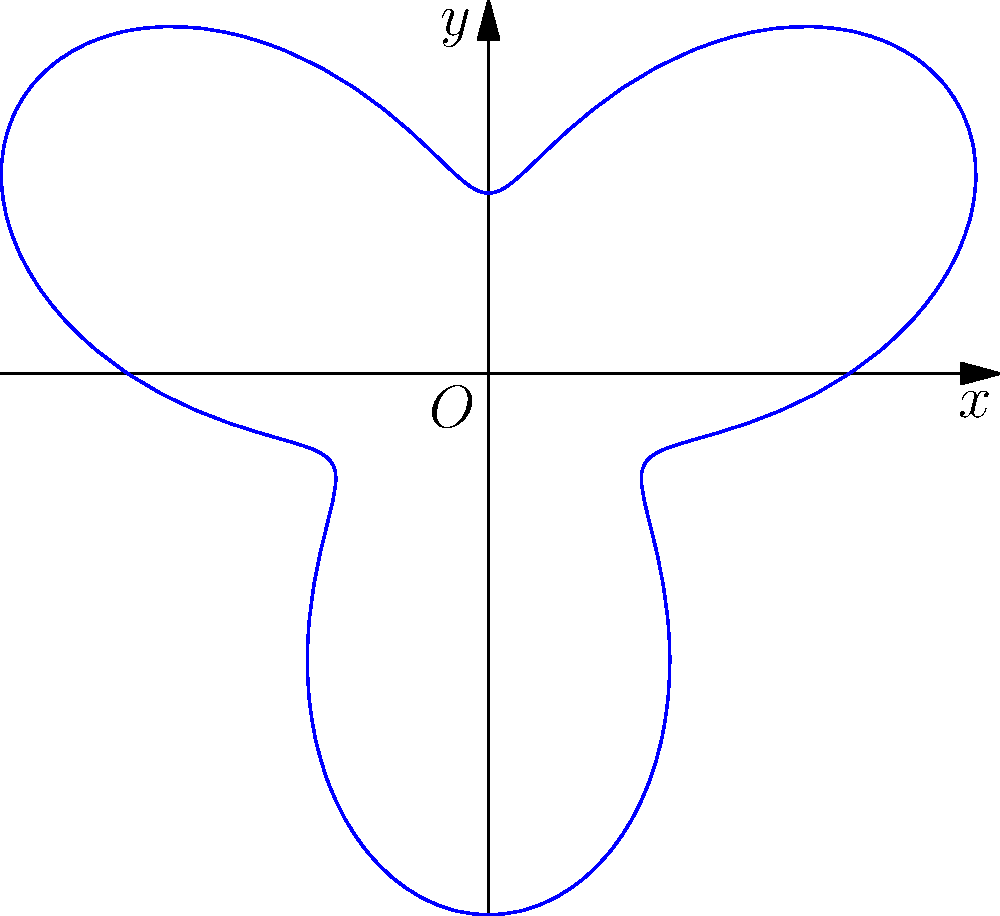In honor of María Fernanda Zúñiga, you want to graph the shape of a traditional Chilean cueca dance pattern in polar form. If the equation $r = 2 + \sin(3\theta)$ represents the dance pattern, what is the maximum number of petals or loops in the resulting polar graph? To determine the number of petals or loops in the polar graph, we need to follow these steps:

1) The general form of the equation is $r = a + b\sin(n\theta)$ or $r = a + b\cos(n\theta)$, where $n$ determines the number of petals.

2) In our case, $r = 2 + \sin(3\theta)$, so $n = 3$.

3) For odd values of $n$, the number of petals is equal to $n$.

4) Since $n = 3$ (an odd number), the graph will have 3 petals.

5) We can confirm this by looking at the provided graph, which clearly shows 3 loops or petals.

This three-petal shape is reminiscent of the flowing movements in the cueca dance, capturing the essence of the traditional Chilean dance that María Fernanda Zúñiga might perform.
Answer: 3 petals 